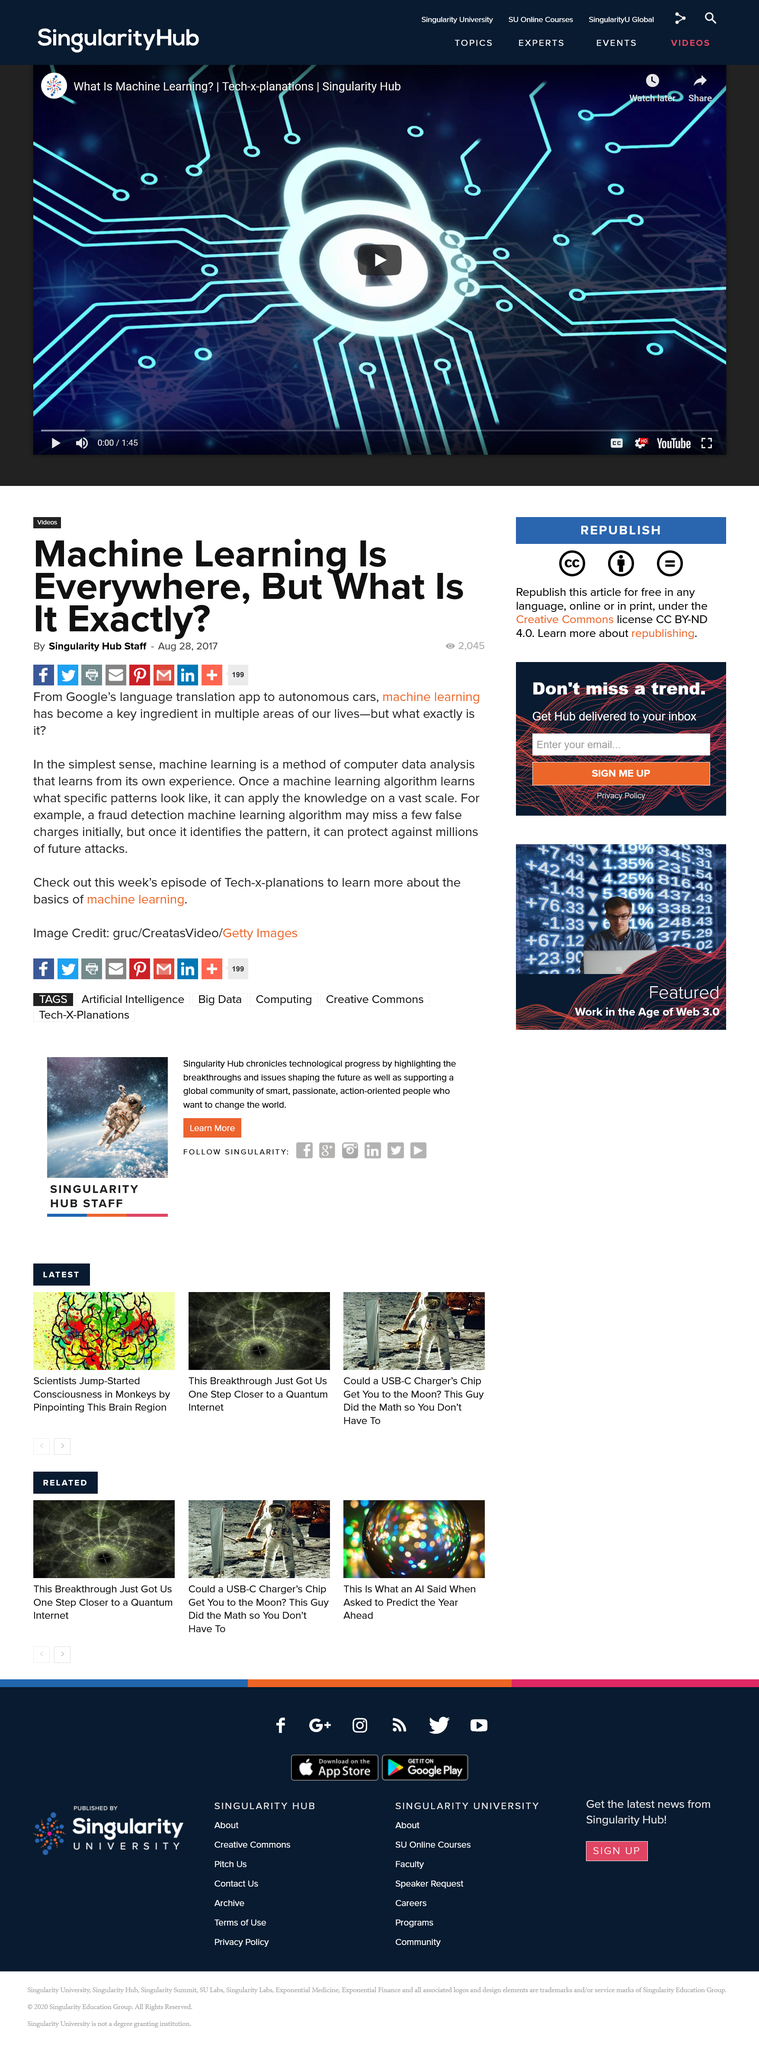Identify some key points in this picture. Machine learning is a process of analyzing data using algorithms that enable a system to improve its performance on a specific task over time, through experience and exposure to new data. The article was published in 2017. The article was written by the Singularity Hub Staff. 